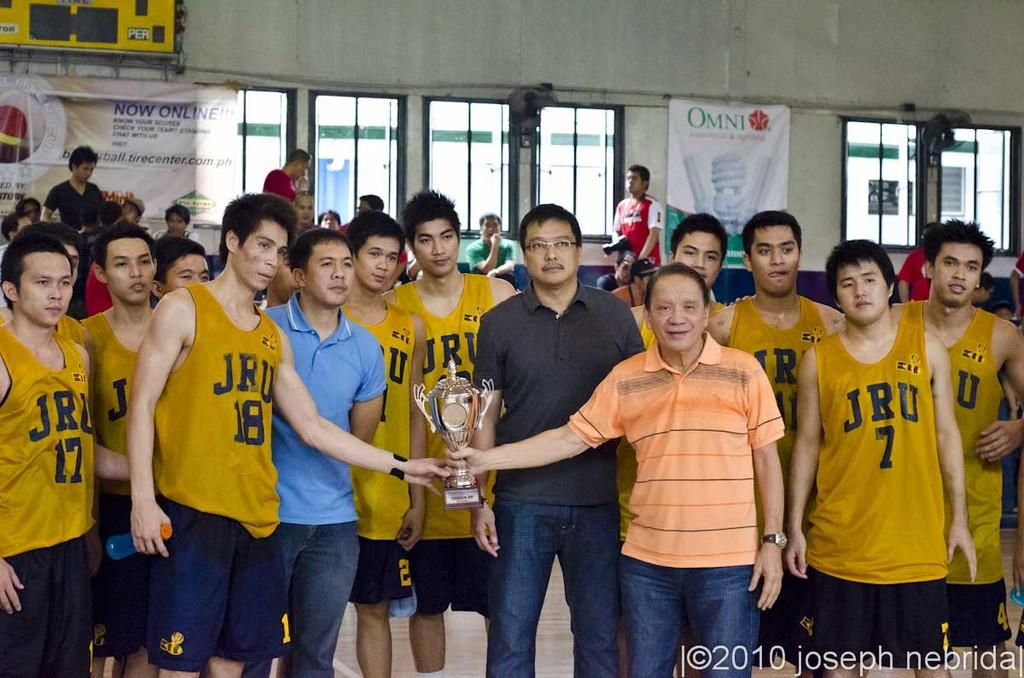<image>
Summarize the visual content of the image. People wearing JRU jerseys are posing with a man holding a trophy. 